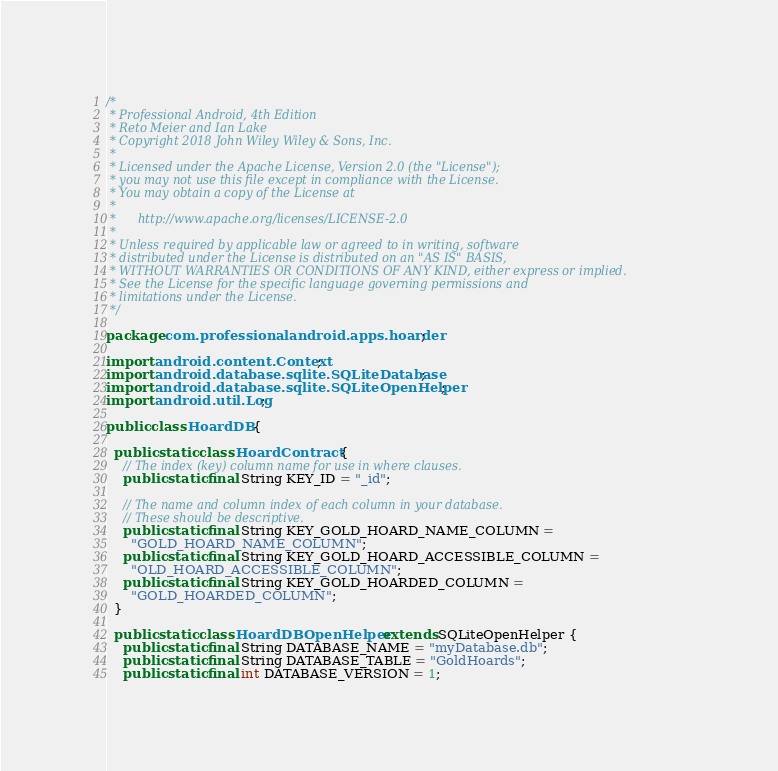<code> <loc_0><loc_0><loc_500><loc_500><_Java_>/*
 * Professional Android, 4th Edition
 * Reto Meier and Ian Lake
 * Copyright 2018 John Wiley Wiley & Sons, Inc.
 *
 * Licensed under the Apache License, Version 2.0 (the "License");
 * you may not use this file except in compliance with the License.
 * You may obtain a copy of the License at
 *
 *      http://www.apache.org/licenses/LICENSE-2.0
 *
 * Unless required by applicable law or agreed to in writing, software
 * distributed under the License is distributed on an "AS IS" BASIS,
 * WITHOUT WARRANTIES OR CONDITIONS OF ANY KIND, either express or implied.
 * See the License for the specific language governing permissions and
 * limitations under the License.
 */

package com.professionalandroid.apps.hoarder;

import android.content.Context;
import android.database.sqlite.SQLiteDatabase;
import android.database.sqlite.SQLiteOpenHelper;
import android.util.Log;

public class HoardDB {

  public static class HoardContract {
    // The index (key) column name for use in where clauses.
    public static final String KEY_ID = "_id";

    // The name and column index of each column in your database.
    // These should be descriptive.
    public static final String KEY_GOLD_HOARD_NAME_COLUMN =
      "GOLD_HOARD_NAME_COLUMN";
    public static final String KEY_GOLD_HOARD_ACCESSIBLE_COLUMN =
      "OLD_HOARD_ACCESSIBLE_COLUMN";
    public static final String KEY_GOLD_HOARDED_COLUMN =
      "GOLD_HOARDED_COLUMN";
  }

  public static class HoardDBOpenHelper extends SQLiteOpenHelper {
    public static final String DATABASE_NAME = "myDatabase.db";
    public static final String DATABASE_TABLE = "GoldHoards";
    public static final int DATABASE_VERSION = 1;
</code> 